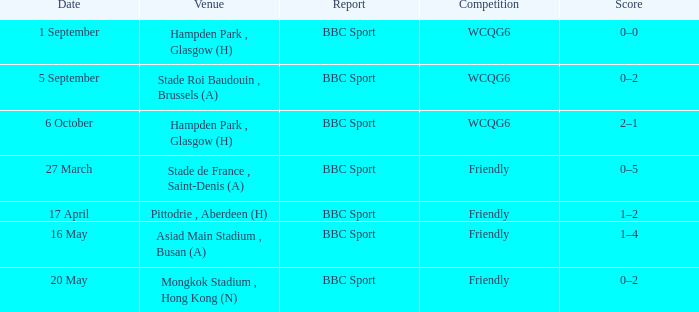Who reported the game on 6 october? BBC Sport. 